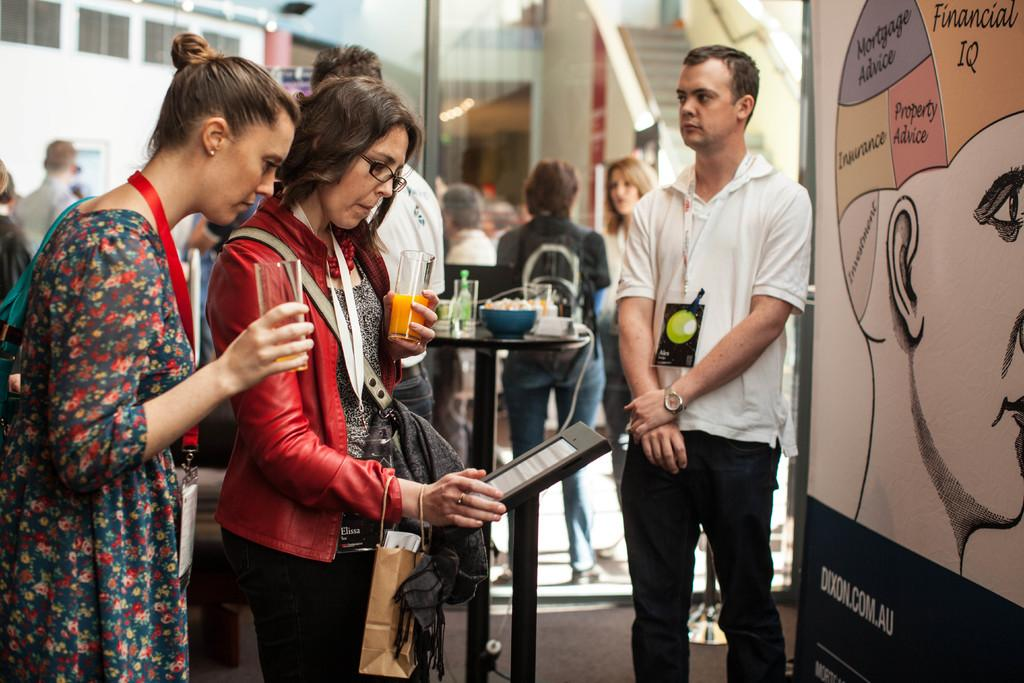How many women are in the image? There are two women in the image. What are the women doing in the image? The women are standing and holding a glass of drink in their hands. What is in front of the women? There is an object in front of the women. Can you describe the scene in the background of the image? There are other persons in the background of the image. What type of light is being used to illuminate the women in the image? There is no specific mention of a light source in the image, so it cannot be determined what type of light is being used. 